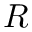<formula> <loc_0><loc_0><loc_500><loc_500>R</formula> 